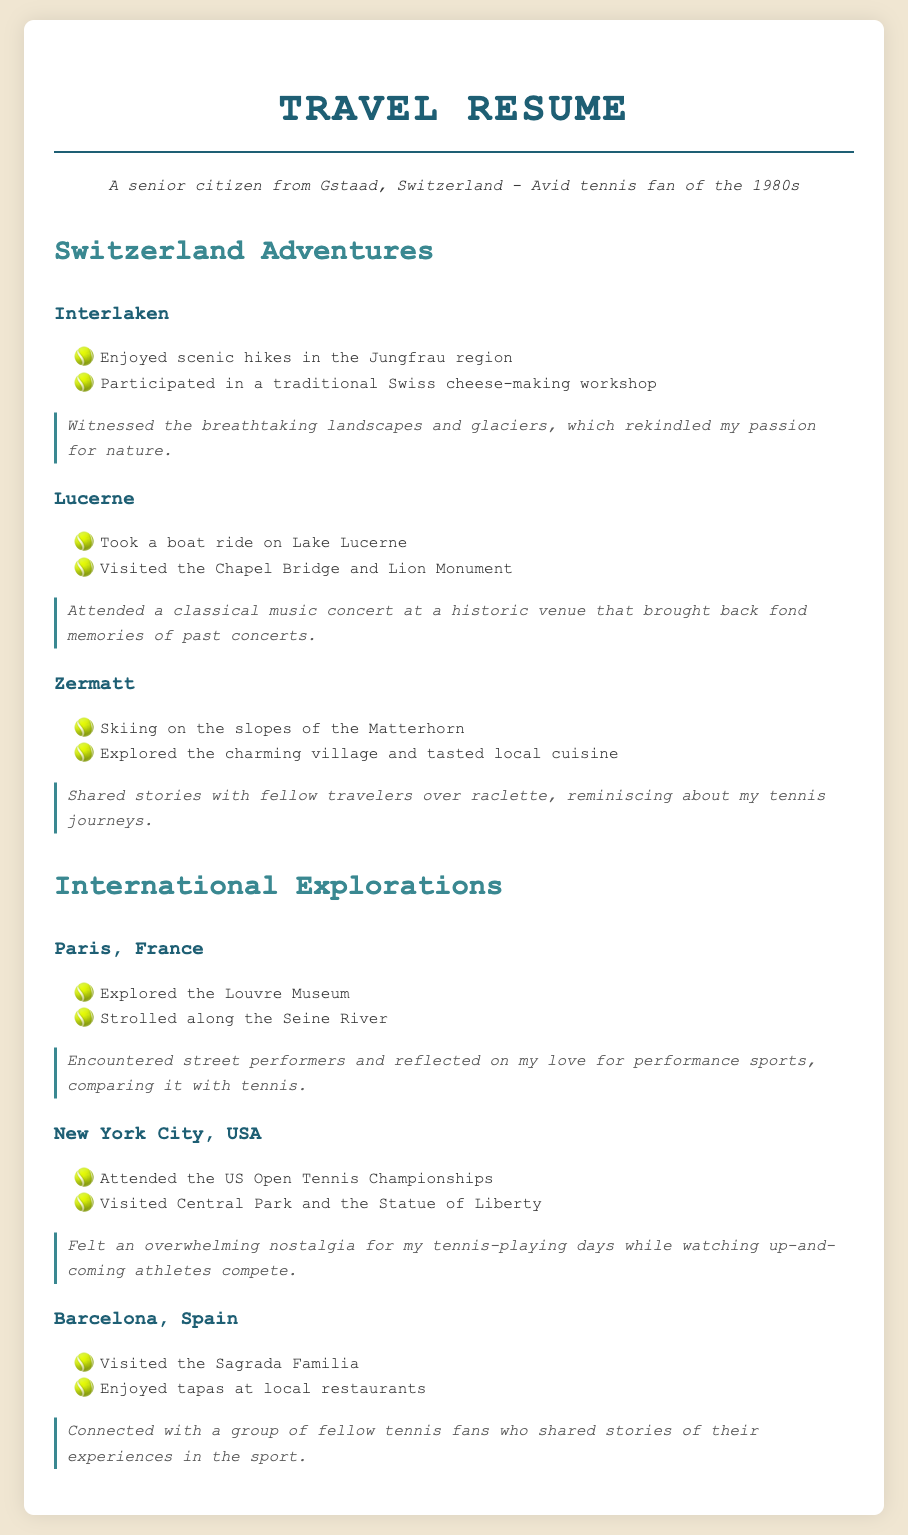What destinations were visited in Switzerland? The document lists the destinations visited in Switzerland: Interlaken, Lucerne, and Zermatt.
Answer: Interlaken, Lucerne, Zermatt What activity was enjoyed in Interlaken? One of the activities enjoyed in Interlaken was participating in a traditional Swiss cheese-making workshop.
Answer: Cheese-making workshop What international city was visited for the US Open Tennis Championships? The document mentions that the US Open Tennis Championships were attended in New York City.
Answer: New York City What memorable experience was shared in Zermatt? In Zermatt, the memorable experience involved sharing stories with fellow travelers over raclette.
Answer: Sharing stories over raclette Which location is associated with a classical music concert? The location associated with a classical music concert is Lucerne.
Answer: Lucerne What sport ties together the experiences shared in the destinations? The sport tying together the experiences shared in the destinations is tennis.
Answer: Tennis How many international locations were mentioned in the document? The document mentions three international locations: Paris, New York City, and Barcelona.
Answer: Three What scenic activity was enjoyed in the Jungfrau region? The scenic activity enjoyed in the Jungfrau region was hiking.
Answer: Hiking Which dish was specifically mentioned in Zermatt's dining experience? The document mentions raclette as the specific dish tasted in Zermatt.
Answer: Raclette 